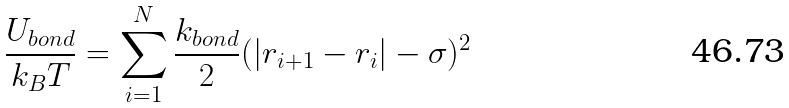<formula> <loc_0><loc_0><loc_500><loc_500>\frac { U _ { b o n d } } { k _ { B } T } = \sum _ { i = 1 } ^ { N } \frac { k _ { b o n d } } { 2 } ( | { r } _ { i + 1 } - { r } _ { i } | - \sigma ) ^ { 2 }</formula> 